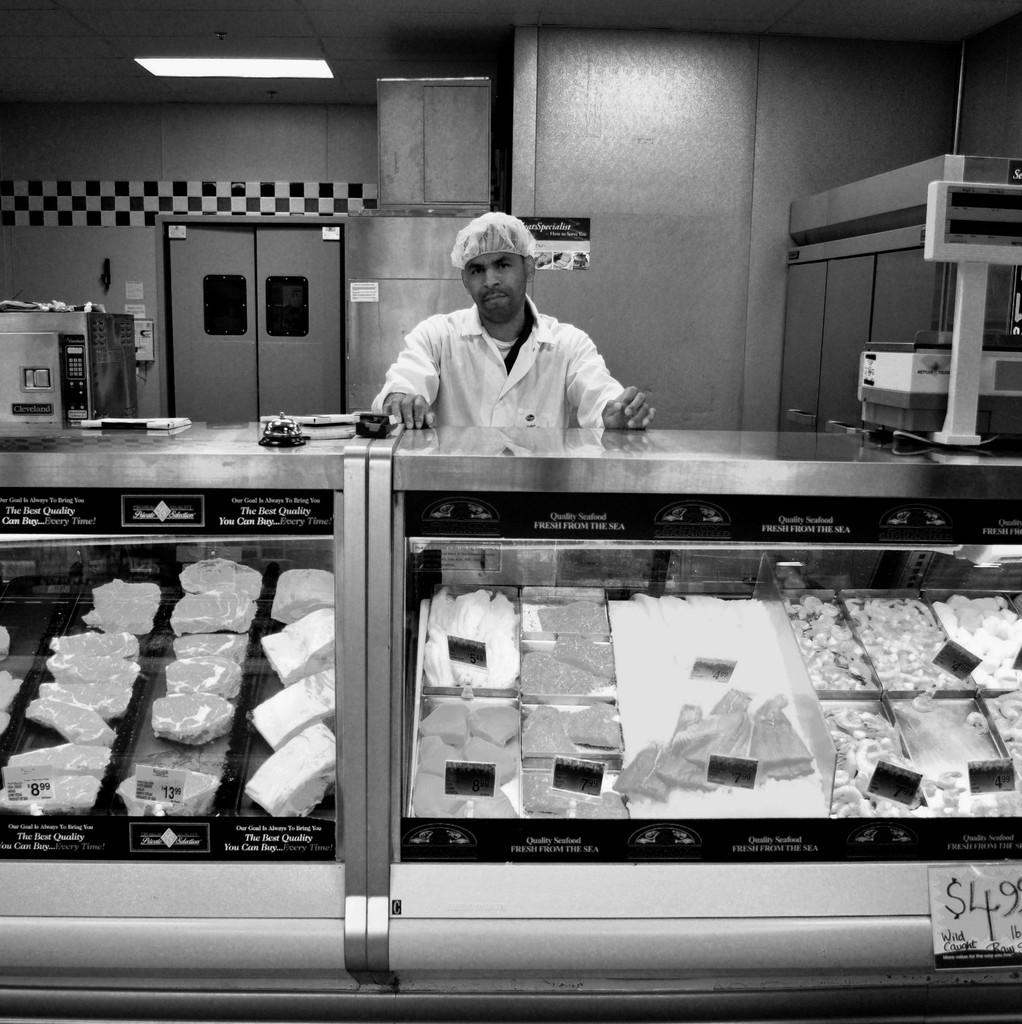<image>
Give a short and clear explanation of the subsequent image. Meat Deli kitchen of a man preparing meat products for customers; sign saying Wild Caught 4.99 LB. 